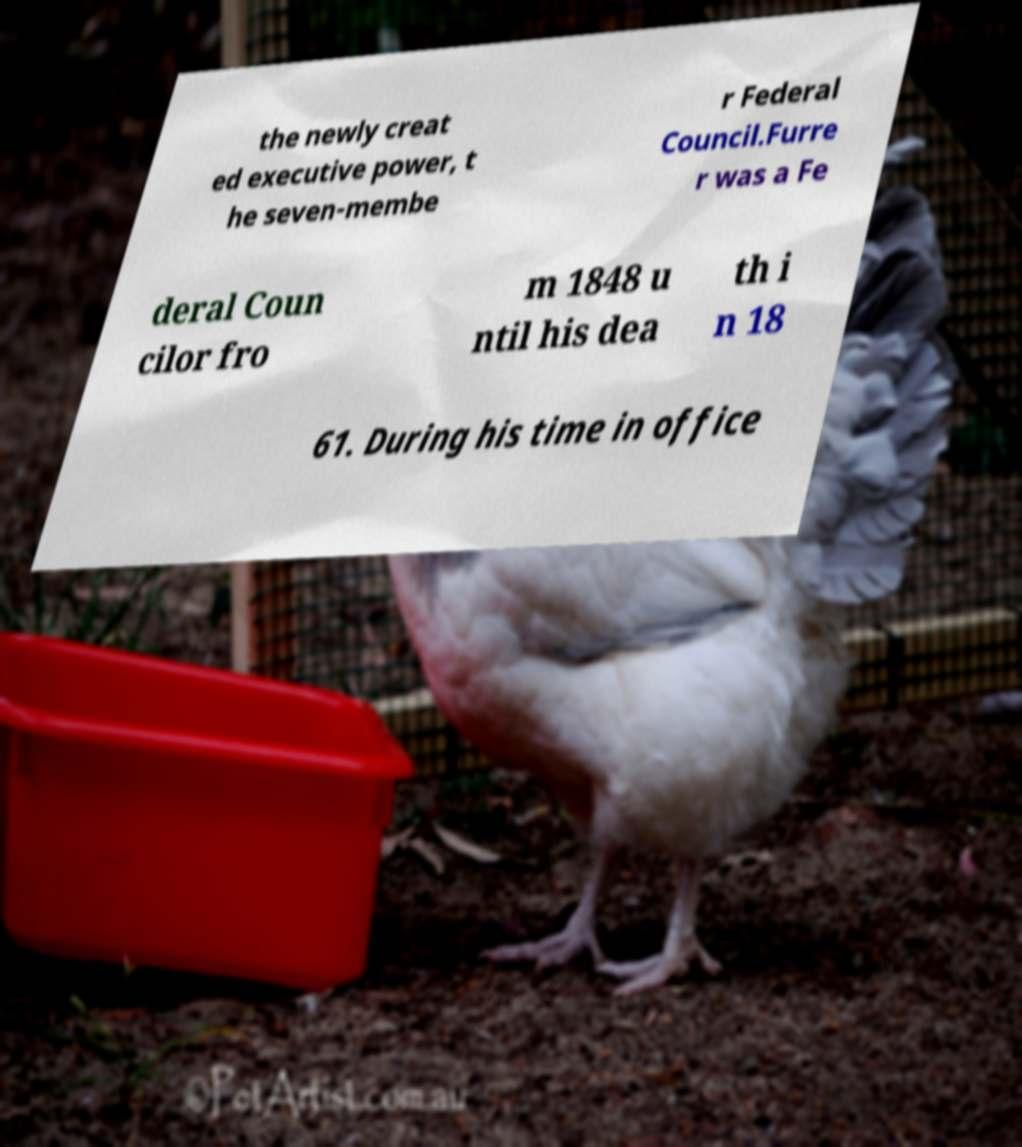For documentation purposes, I need the text within this image transcribed. Could you provide that? the newly creat ed executive power, t he seven-membe r Federal Council.Furre r was a Fe deral Coun cilor fro m 1848 u ntil his dea th i n 18 61. During his time in office 